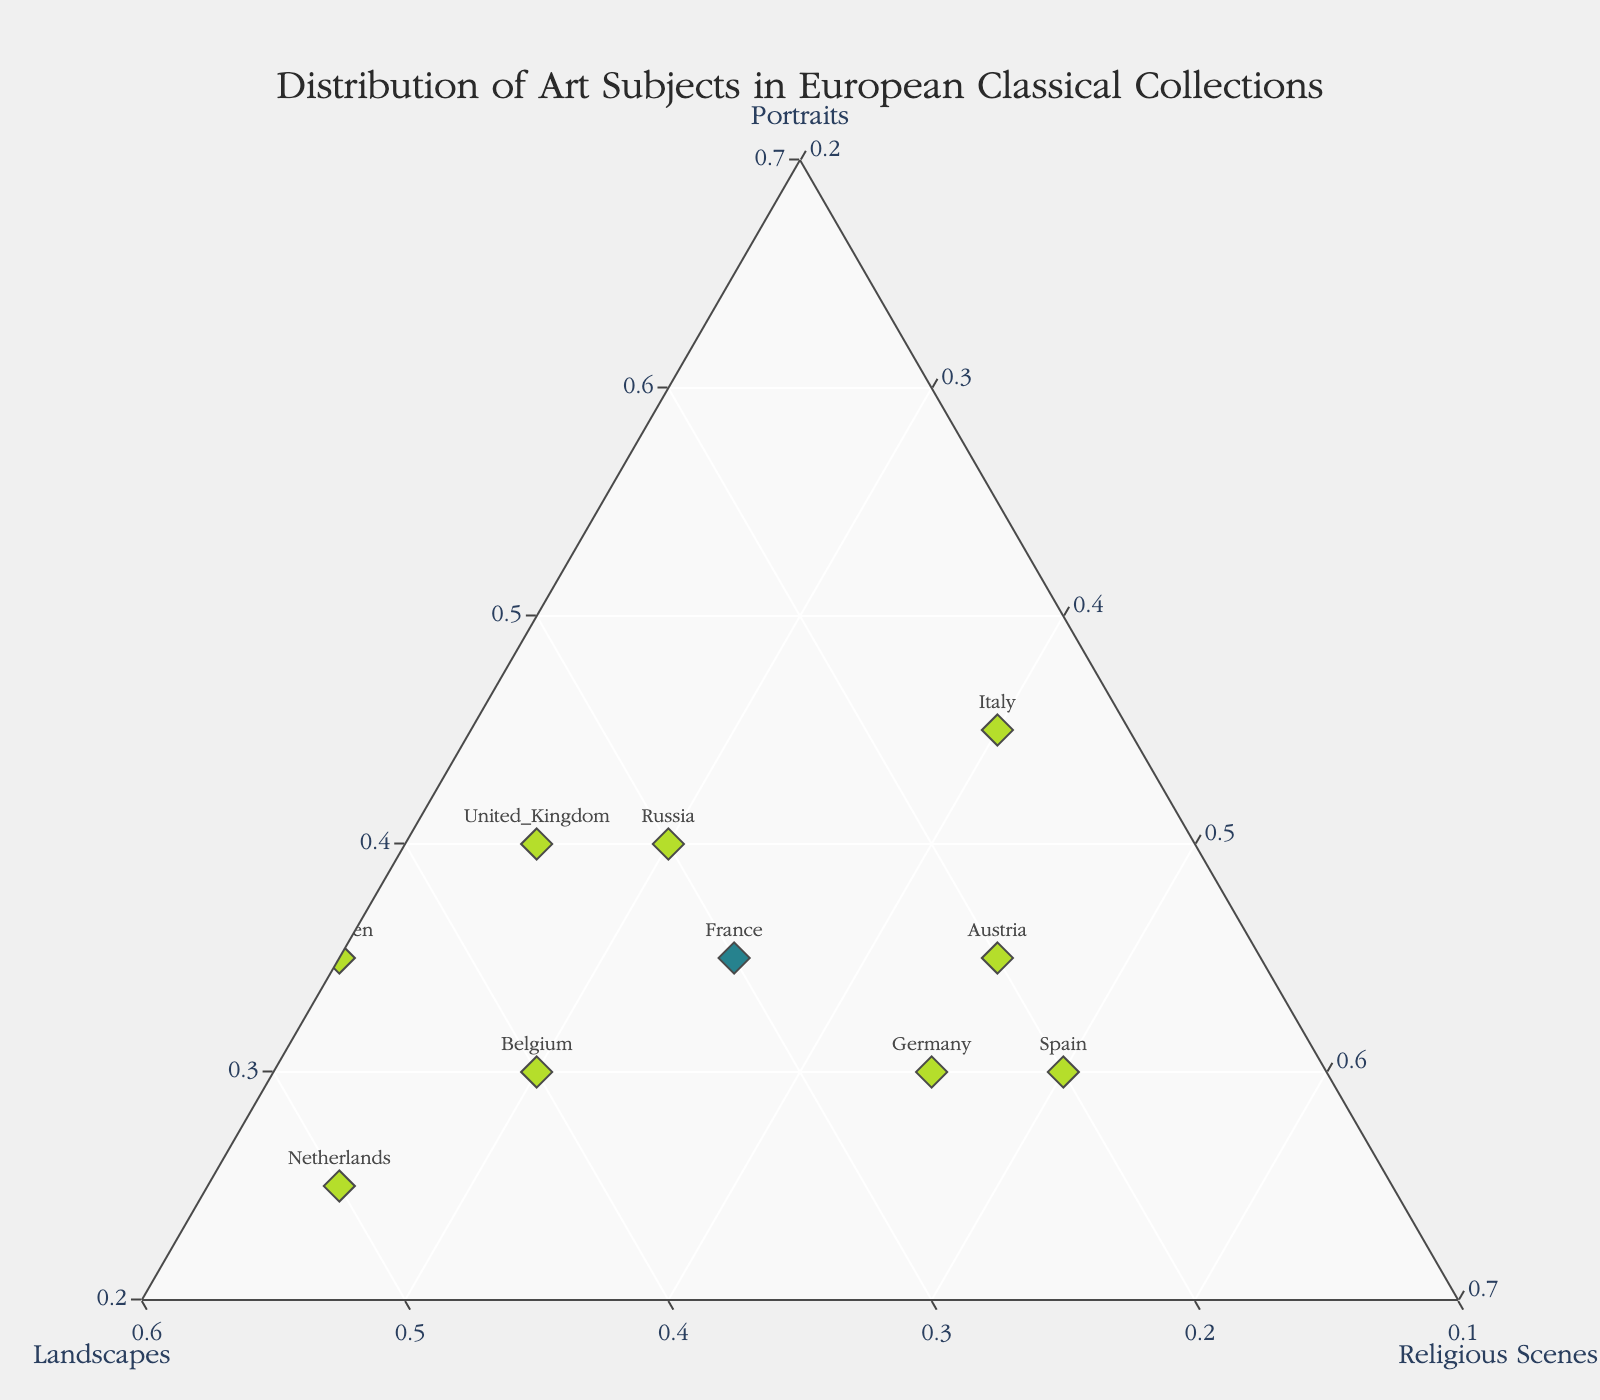What is the title of the plot? The title is located at the top center of the plot and reads "Distribution of Art Subjects in European Classical Collections".
Answer: Distribution of Art Subjects in European Classical Collections Which country has the highest proportion of landscapes? Referring to the plot, the point farthest along the Landscapes axis represents the country with the highest proportion of landscapes. This point belongs to the Netherlands with a proportion of 0.50 for landscapes.
Answer: Netherlands How many countries have a portrait proportion higher than 0.35? By looking at the plot, identify points where the Portraits axis value is above 0.35. The countries that meet this criterion are Italy (0.45), United Kingdom (0.40), and Russia (0.40), totaling three countries.
Answer: 3 Which country has the lowest proportion of religious scenes, and what is that proportion? Find the country with the point closest to the Portraits-Landscapes base (farthest from the Religious Scenes axis). Sweden is identified with 0.20 for religious scenes.
Answer: Sweden, 0.20 Compare France and Spain — which country has a more balanced distribution of the three subjects? Examine both countries' positions on the plot. France's proximity to the center compared to Spain's location closer to the Religious Scenes vertex indicates a more balanced distribution across all three subjects.
Answer: France What is the approximate proportion of landscapes in Sweden's classical art collections? Find Sweden's location on the plot and check the value on the Landscapes axis. The proportion of landscapes for Sweden is approximately 0.45.
Answer: 0.45 Which country exhibits a majority of religious scenes in its classical art collections? Find the country closest to the Religious Scenes vertex with a value greater than 0.50. Spain has the highest proportion with 0.50.
Answer: Spain What percentage of countries have over 40% portraits in their collections? Out of the 10 countries listed, identify how many surpass the 0.40 mark in the Portraits category. The countries are Italy, United Kingdom, and Russia, totaling three. The percentage is (3/10) * 100 = 30%.
Answer: 30% Which axis represents religious scenes? The axis labeling Religious Scenes should be identified by its title on the plot. The axis is usually annotated directly on the plot with the title "Religious Scenes".
Answer: Religious Scenes 